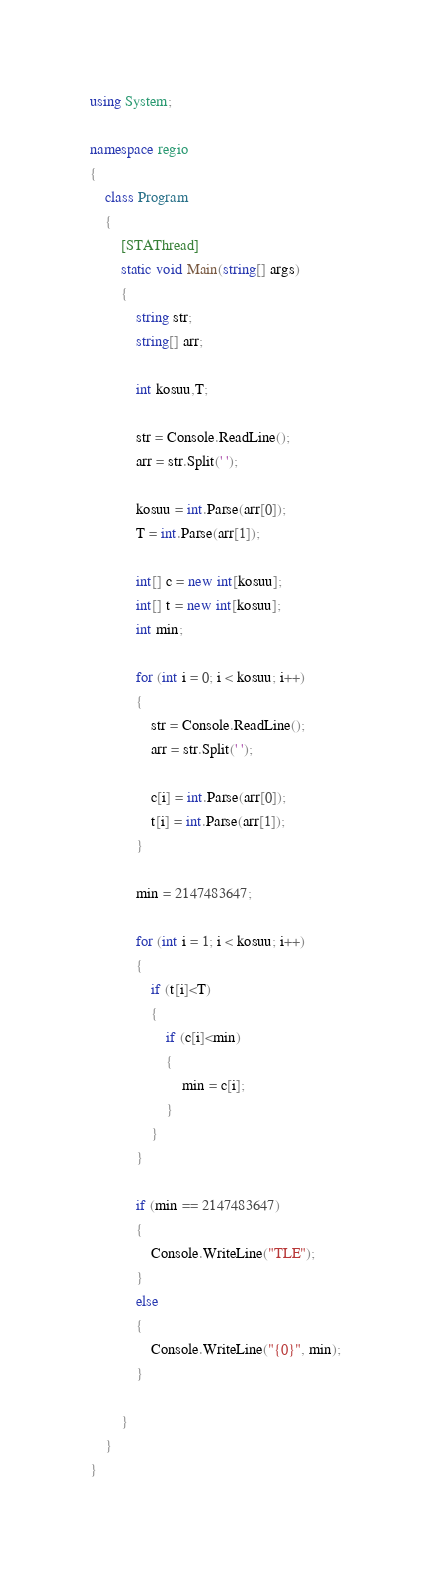Convert code to text. <code><loc_0><loc_0><loc_500><loc_500><_C#_>using System;

namespace regio
{
    class Program
    {
        [STAThread]
        static void Main(string[] args)
        {
            string str;
            string[] arr;

            int kosuu,T;

            str = Console.ReadLine();
            arr = str.Split(' ');

            kosuu = int.Parse(arr[0]);
            T = int.Parse(arr[1]);

            int[] c = new int[kosuu];
            int[] t = new int[kosuu];
            int min;

            for (int i = 0; i < kosuu; i++)
            {
                str = Console.ReadLine();
                arr = str.Split(' ');

                c[i] = int.Parse(arr[0]);
                t[i] = int.Parse(arr[1]);
            }

            min = 2147483647;

            for (int i = 1; i < kosuu; i++)
            {
                if (t[i]<T)
                {
                    if (c[i]<min)
                    {
                        min = c[i];
                    }
                }
            }

            if (min == 2147483647)
            {
                Console.WriteLine("TLE");
            }
            else
            {
                Console.WriteLine("{0}", min);
            }

        }
    }
}
</code> 